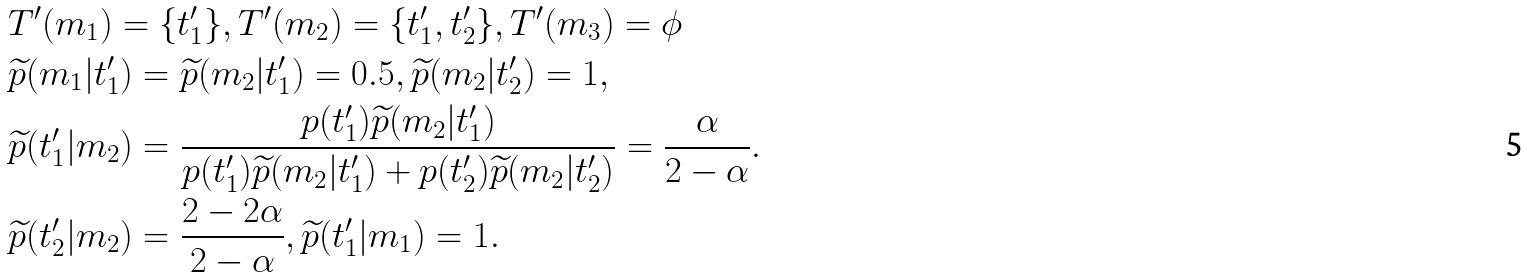<formula> <loc_0><loc_0><loc_500><loc_500>& T ^ { \prime } ( m _ { 1 } ) = \{ t ^ { \prime } _ { 1 } \} , T ^ { \prime } ( m _ { 2 } ) = \{ t ^ { \prime } _ { 1 } , t ^ { \prime } _ { 2 } \} , T ^ { \prime } ( m _ { 3 } ) = \phi \\ & \widetilde { p } ( m _ { 1 } | t ^ { \prime } _ { 1 } ) = \widetilde { p } ( m _ { 2 } | t ^ { \prime } _ { 1 } ) = 0 . 5 , \widetilde { p } ( m _ { 2 } | t ^ { \prime } _ { 2 } ) = 1 , \\ & \widetilde { p } ( t ^ { \prime } _ { 1 } | m _ { 2 } ) = \frac { p ( t ^ { \prime } _ { 1 } ) \widetilde { p } ( m _ { 2 } | t ^ { \prime } _ { 1 } ) } { p ( t ^ { \prime } _ { 1 } ) \widetilde { p } ( m _ { 2 } | t ^ { \prime } _ { 1 } ) + p ( t ^ { \prime } _ { 2 } ) \widetilde { p } ( m _ { 2 } | t ^ { \prime } _ { 2 } ) } = \frac { \alpha } { 2 - \alpha } . \\ & \widetilde { p } ( t ^ { \prime } _ { 2 } | m _ { 2 } ) = \frac { 2 - 2 \alpha } { 2 - \alpha } , \widetilde { p } ( t ^ { \prime } _ { 1 } | m _ { 1 } ) = 1 .</formula> 